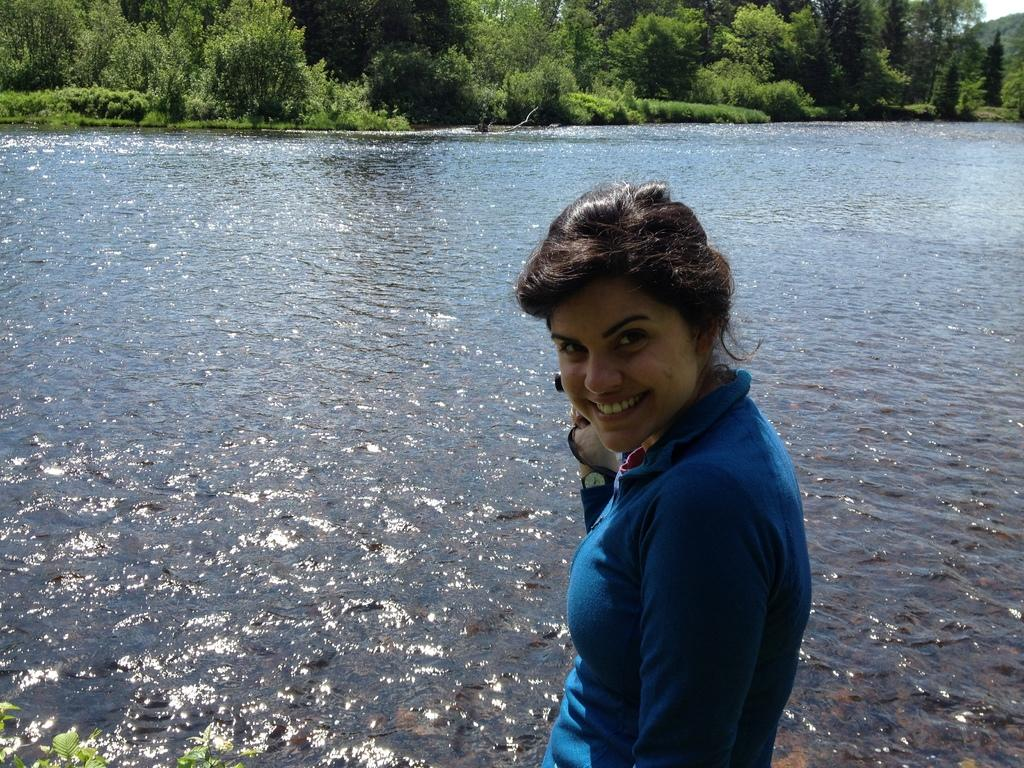Who is the main subject in the image? There is a woman in the image. What is the woman doing in the image? The woman is standing and smiling. What is the woman wearing in the image? The woman is wearing a blue T-shirt. What can be seen in the background of the image? There are plants and trees in the background of the image. What else is visible in the image? There is water visible in the image. How many sisters does the woman have in the image? There is no information about the woman's sisters in the image. Is there a slope visible in the image? There is no slope visible in the image. 